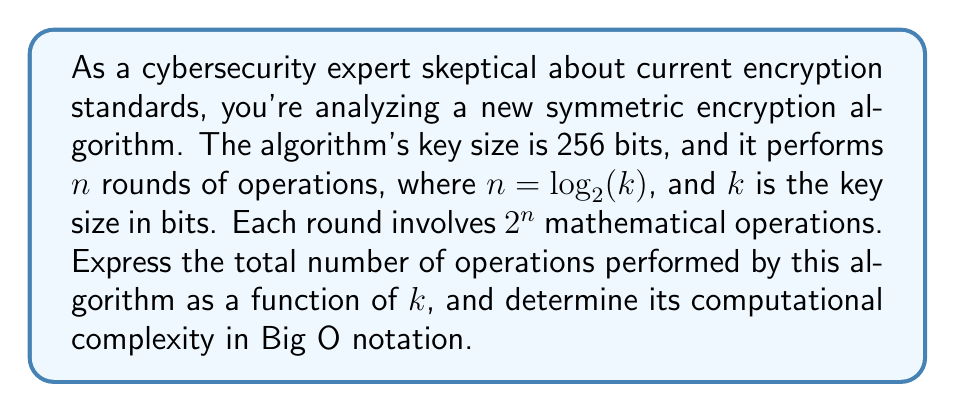Help me with this question. Let's approach this step-by-step:

1) First, we need to express $n$ in terms of $k$:
   $n = \log_2(k)$

2) Each round performs $2^n$ operations. We can express this in terms of $k$:
   $2^n = 2^{\log_2(k)} = k$ (using the property $a^{\log_a(x)} = x$)

3) The total number of rounds is $n = \log_2(k)$

4) Therefore, the total number of operations is:
   $\text{Total operations} = (\text{operations per round}) \times (\text{number of rounds})$
   $= k \times \log_2(k)$

5) To determine the computational complexity in Big O notation, we consider the growth rate of this function as $k$ increases. The function $k \log_2(k)$ grows more slowly than $k^2$ but faster than $k$.

6) In Big O notation, we express this as $O(k \log k)$

This analysis reveals that while the algorithm's complexity is superlinear, it's still more efficient than quadratic algorithms. However, as a skeptical cybersecurity expert, you might note that this doesn't necessarily guarantee the algorithm's security, as computational complexity is just one aspect of cryptographic strength.
Answer: The total number of operations is $k \log_2(k)$, and the computational complexity is $O(k \log k)$. 